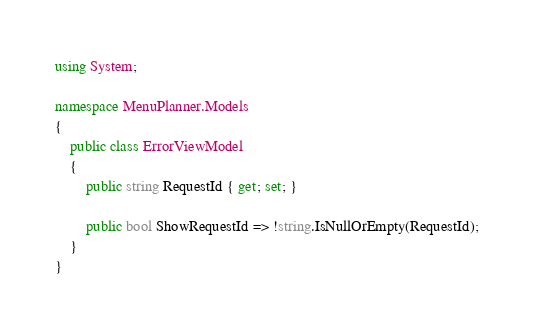Convert code to text. <code><loc_0><loc_0><loc_500><loc_500><_C#_>using System;

namespace MenuPlanner.Models
{
    public class ErrorViewModel
    {
        public string RequestId { get; set; }

        public bool ShowRequestId => !string.IsNullOrEmpty(RequestId);
    }
}</code> 